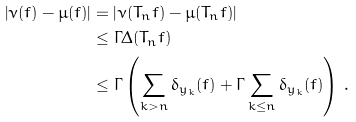<formula> <loc_0><loc_0><loc_500><loc_500>\left | \nu ( f ) - \mu ( f ) \right | & = \left | \nu ( T _ { n } f ) - \mu ( T _ { n } f ) \right | \\ & \leq \Gamma \Delta ( T _ { n } f ) \\ & \leq \Gamma \left ( \sum _ { k > n } \delta _ { y _ { k } } ( f ) + \Gamma \sum _ { k \leq n } \delta _ { y _ { k } } ( f ) \right ) \, . \\</formula> 